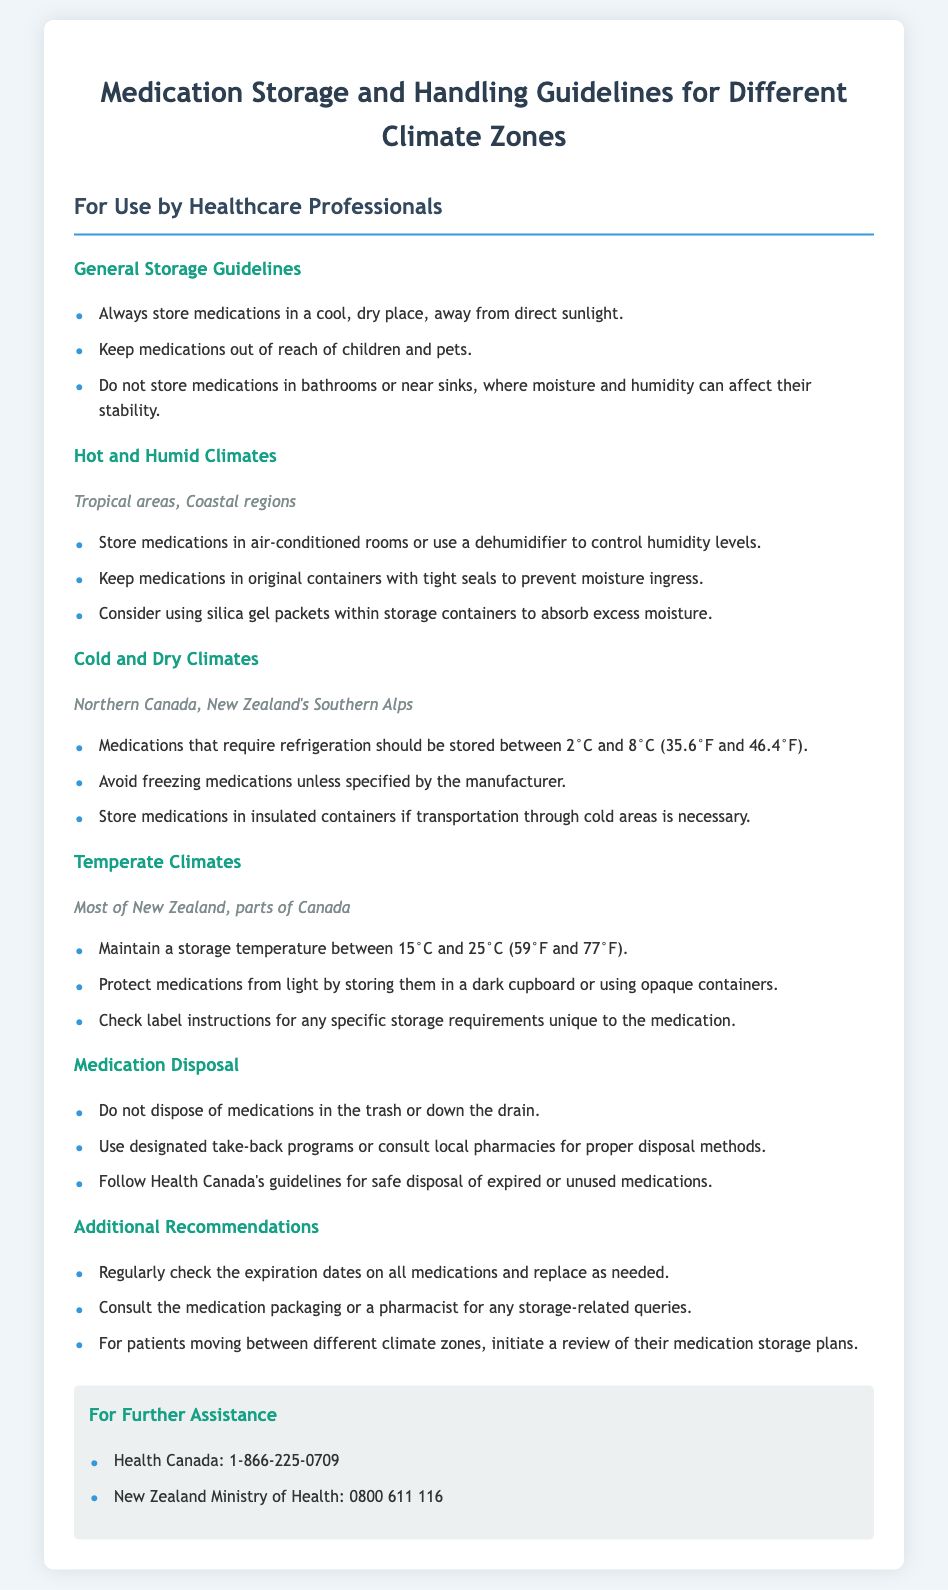What should the storage temperature be in temperate climates? Temperate climates require a storage temperature between 15°C and 25°C.
Answer: 15°C and 25°C What is the contact number for Health Canada? The document provides Health Canada's contact number in the additional information section.
Answer: 1-866-225-0709 What should you avoid doing with medications in bathrooms? The document specifies that medications should not be stored in bathrooms due to moisture and humidity.
Answer: Moisture and humidity What type of climates does the guideline suggest using a dehumidifier? Hot and humid climates are specified for using a dehumidifier to control humidity levels.
Answer: Hot and humid climates Which regions are included in cold and dry climates? The document lists Northern Canada and New Zealand's Southern Alps as cold and dry climates.
Answer: Northern Canada, New Zealand's Southern Alps What method is recommended for disposing of medications? The document suggests using designated take-back programs or consulting local pharmacies for disposal methods.
Answer: Designated take-back programs What should you store medications in to protect them from light? The document mentions storing medications in a dark cupboard or using opaque containers for light protection.
Answer: Dark cupboard or opaque containers What is recommended for patients moving between climate zones? The document indicates that a review of their medication storage plans should be initiated for patients moving between climate zones.
Answer: Review medication storage plans 